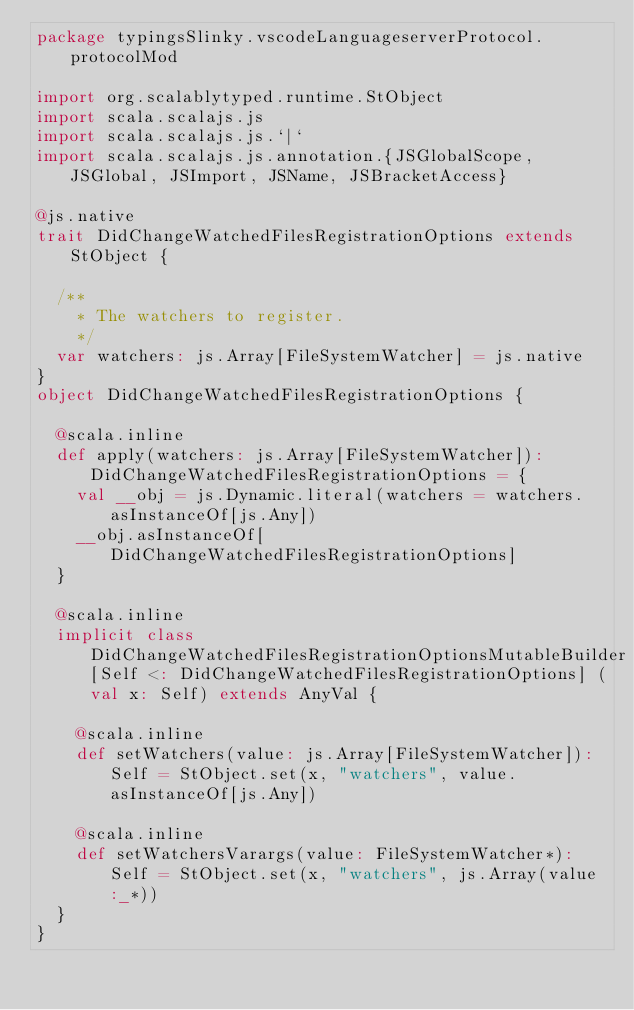<code> <loc_0><loc_0><loc_500><loc_500><_Scala_>package typingsSlinky.vscodeLanguageserverProtocol.protocolMod

import org.scalablytyped.runtime.StObject
import scala.scalajs.js
import scala.scalajs.js.`|`
import scala.scalajs.js.annotation.{JSGlobalScope, JSGlobal, JSImport, JSName, JSBracketAccess}

@js.native
trait DidChangeWatchedFilesRegistrationOptions extends StObject {
  
  /**
    * The watchers to register.
    */
  var watchers: js.Array[FileSystemWatcher] = js.native
}
object DidChangeWatchedFilesRegistrationOptions {
  
  @scala.inline
  def apply(watchers: js.Array[FileSystemWatcher]): DidChangeWatchedFilesRegistrationOptions = {
    val __obj = js.Dynamic.literal(watchers = watchers.asInstanceOf[js.Any])
    __obj.asInstanceOf[DidChangeWatchedFilesRegistrationOptions]
  }
  
  @scala.inline
  implicit class DidChangeWatchedFilesRegistrationOptionsMutableBuilder[Self <: DidChangeWatchedFilesRegistrationOptions] (val x: Self) extends AnyVal {
    
    @scala.inline
    def setWatchers(value: js.Array[FileSystemWatcher]): Self = StObject.set(x, "watchers", value.asInstanceOf[js.Any])
    
    @scala.inline
    def setWatchersVarargs(value: FileSystemWatcher*): Self = StObject.set(x, "watchers", js.Array(value :_*))
  }
}
</code> 